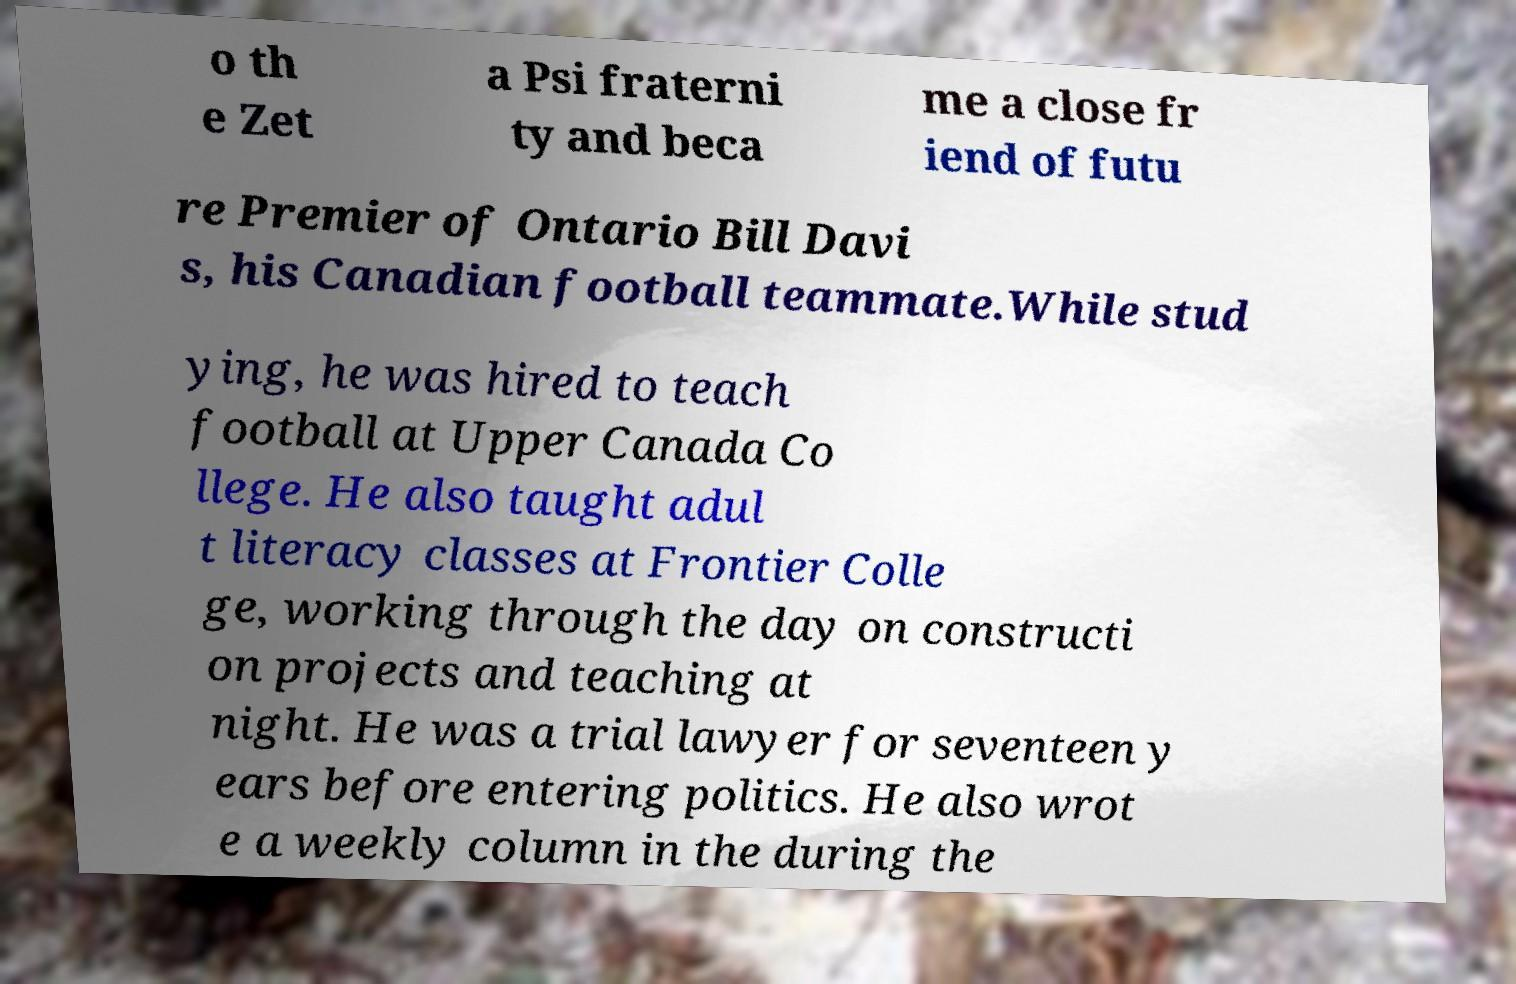Can you accurately transcribe the text from the provided image for me? o th e Zet a Psi fraterni ty and beca me a close fr iend of futu re Premier of Ontario Bill Davi s, his Canadian football teammate.While stud ying, he was hired to teach football at Upper Canada Co llege. He also taught adul t literacy classes at Frontier Colle ge, working through the day on constructi on projects and teaching at night. He was a trial lawyer for seventeen y ears before entering politics. He also wrot e a weekly column in the during the 